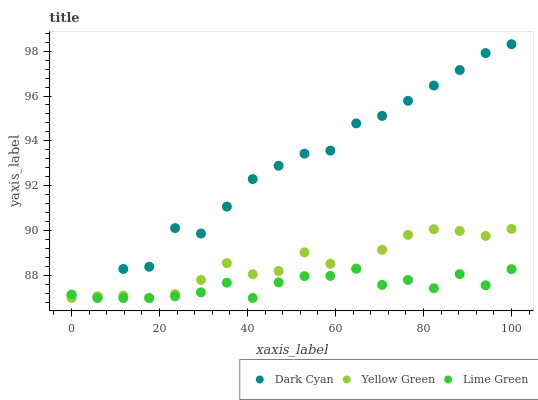Does Lime Green have the minimum area under the curve?
Answer yes or no. Yes. Does Dark Cyan have the maximum area under the curve?
Answer yes or no. Yes. Does Yellow Green have the minimum area under the curve?
Answer yes or no. No. Does Yellow Green have the maximum area under the curve?
Answer yes or no. No. Is Yellow Green the smoothest?
Answer yes or no. Yes. Is Dark Cyan the roughest?
Answer yes or no. Yes. Is Lime Green the smoothest?
Answer yes or no. No. Is Lime Green the roughest?
Answer yes or no. No. Does Lime Green have the lowest value?
Answer yes or no. Yes. Does Dark Cyan have the highest value?
Answer yes or no. Yes. Does Yellow Green have the highest value?
Answer yes or no. No. Does Lime Green intersect Yellow Green?
Answer yes or no. Yes. Is Lime Green less than Yellow Green?
Answer yes or no. No. Is Lime Green greater than Yellow Green?
Answer yes or no. No. 